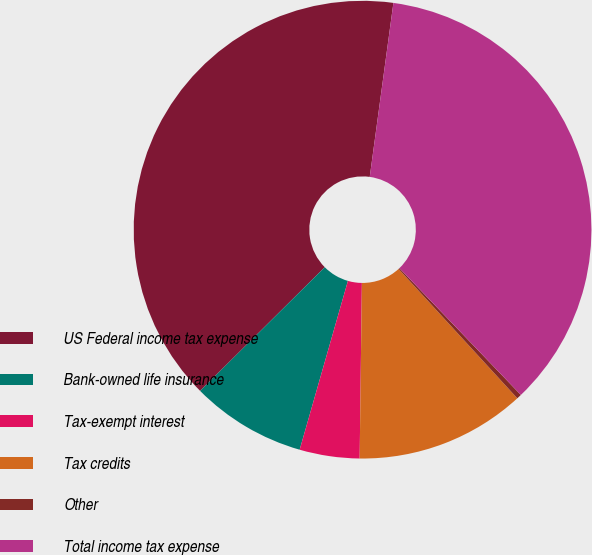<chart> <loc_0><loc_0><loc_500><loc_500><pie_chart><fcel>US Federal income tax expense<fcel>Bank-owned life insurance<fcel>Tax-exempt interest<fcel>Tax credits<fcel>Other<fcel>Total income tax expense<nl><fcel>39.59%<fcel>8.13%<fcel>4.23%<fcel>12.02%<fcel>0.34%<fcel>35.69%<nl></chart> 